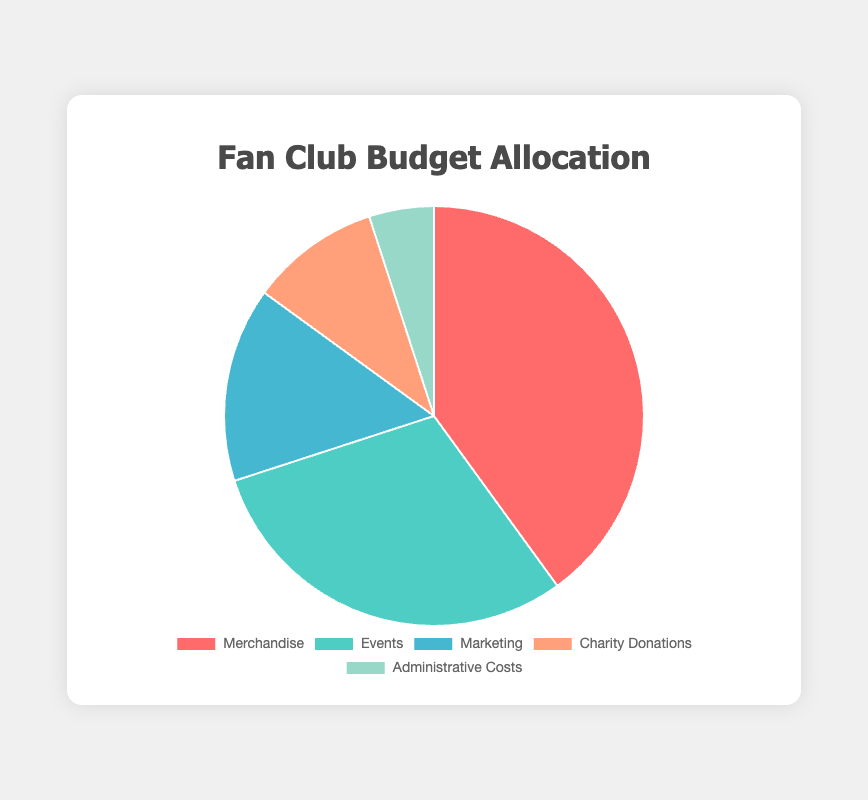What percentage of the total budget is allocated to Merchandise and Marketing combined? Merchandise has 40% and Marketing has 15%. Adding them together, 40% + 15% = 55%.
Answer: 55% Which activity category has the highest budget allocation? By comparing all the percentages in the pie chart, Merchandise has the highest allocation with 40%.
Answer: Merchandise How much total budget is allocated to Events and Charity Donations together? Events have 30% and Charity Donations have 10%. Together, they have 40% of the total budget. The total budget is $10,000, so 40% of $10,000 is $4,000.
Answer: $4,000 What color represents the Administrative Costs category in the pie chart? In the pie chart, the color representing Administrative Costs is a light blue shade.
Answer: light blue Which two categories have the smallest budget allocations? By comparing the percentages, Administrative Costs (5%) and Charity Donations (10%) have the smallest allocations.
Answer: Administrative Costs and Charity Donations How much more budget is allocated to Merchandise than to Charity Donations? Merchandise has 40% of the budget and Charity Donations have 10%. The difference is 40% - 10% = 30%. 30% of the $10,000 total budget is $3,000.
Answer: $3,000 If the total budget is increased by 20%, how much will be the new budget for Marketing? With a 20% increase, the new total budget is $10,000 * 1.20 = $12,000. Marketing is allocated 15%, so 15% of $12,000 is $1,800.
Answer: $1,800 What is the total amount allocated for Office Supplies and Posters together? Office Supplies have $200, and Posters have $800. Summing these amounts gives $200 + $800 = $1,000.
Answer: $1,000 